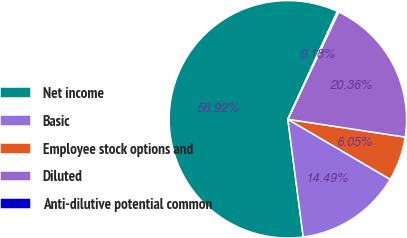Convert chart. <chart><loc_0><loc_0><loc_500><loc_500><pie_chart><fcel>Net income<fcel>Basic<fcel>Employee stock options and<fcel>Diluted<fcel>Anti-dilutive potential common<nl><fcel>58.92%<fcel>14.49%<fcel>6.05%<fcel>20.36%<fcel>0.18%<nl></chart> 